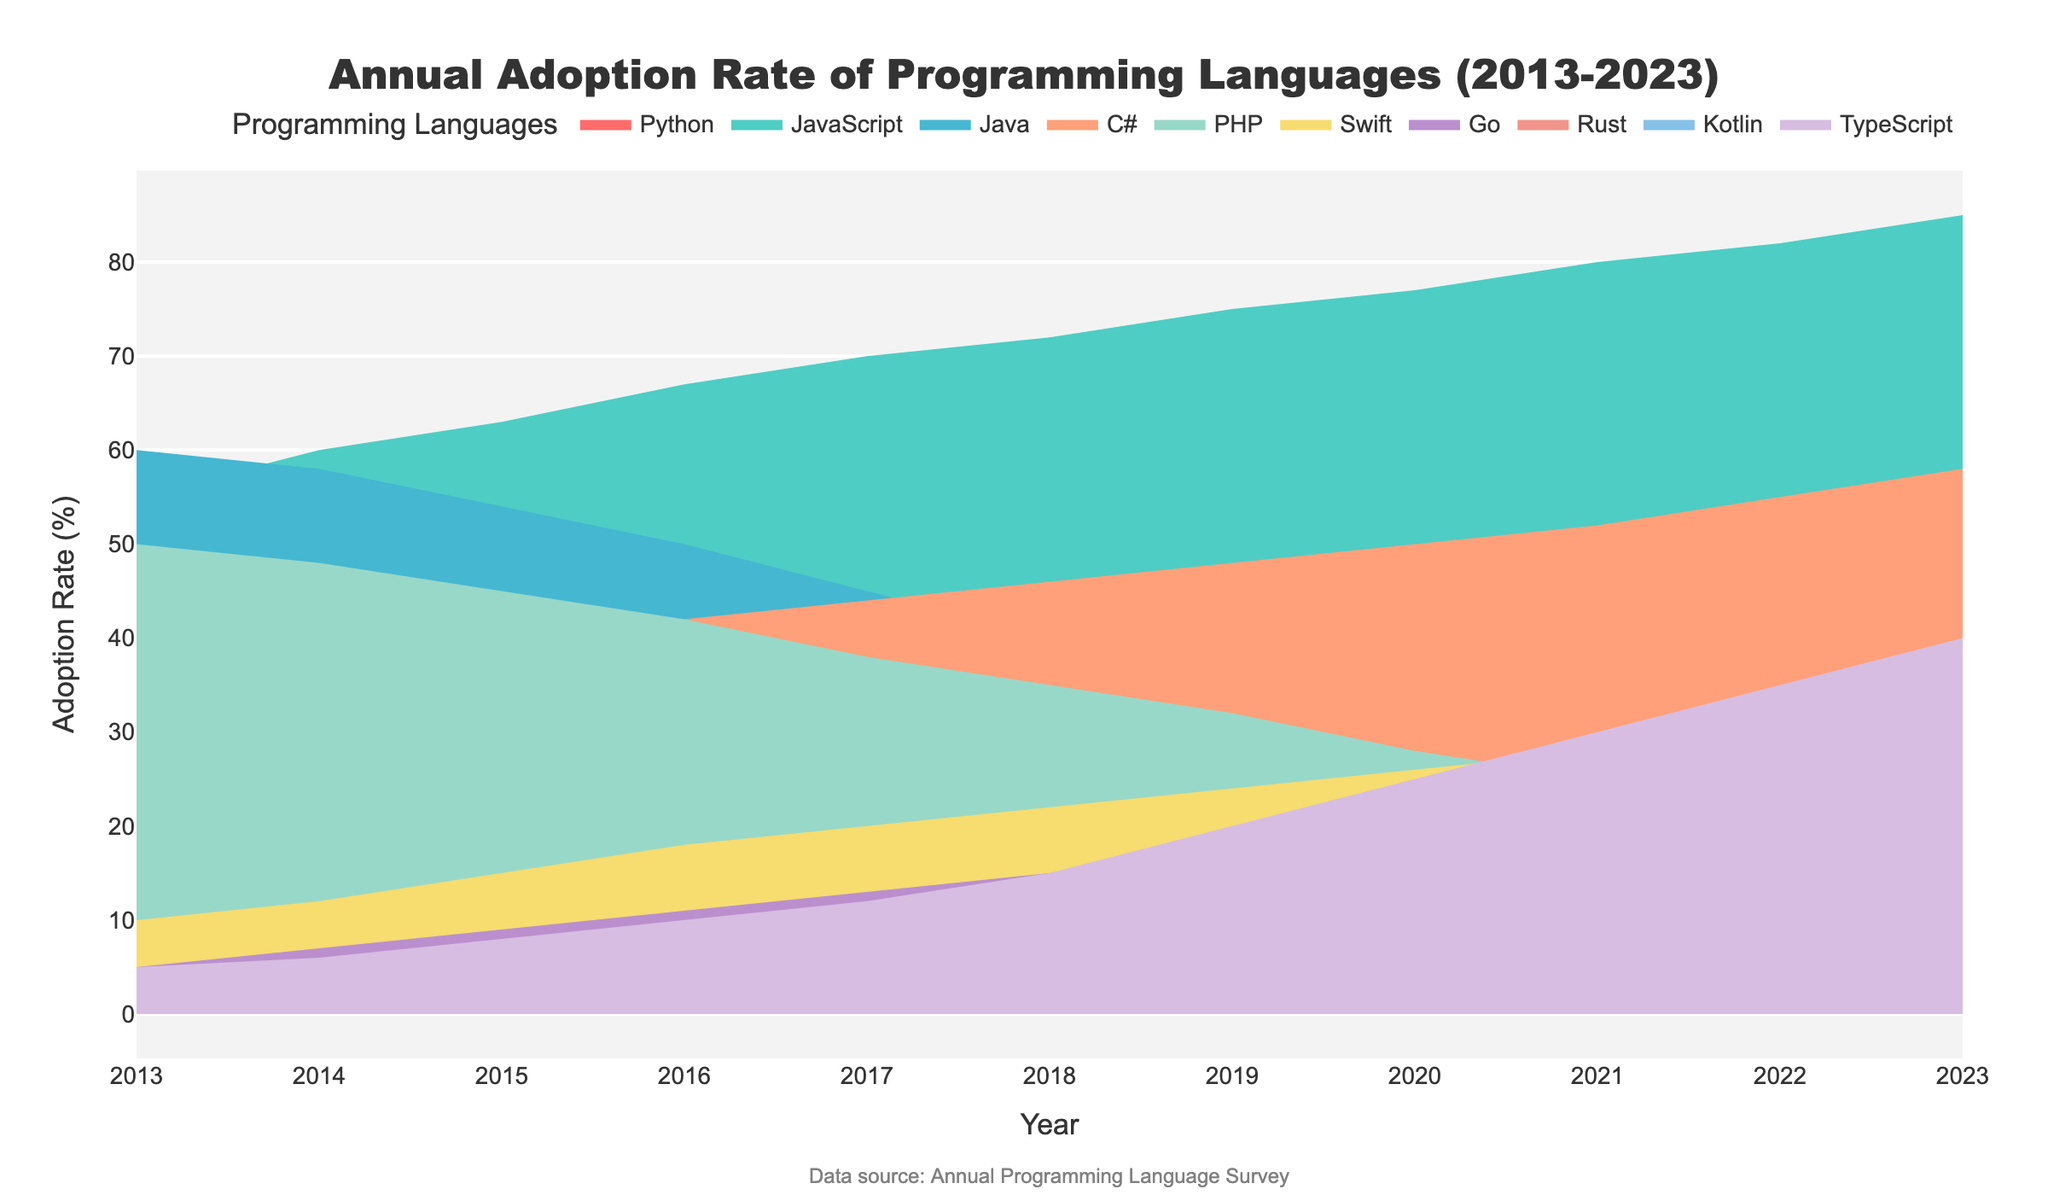What is the title of the chart? The title of the chart is displayed prominently at the top of the figure and reads "Annual Adoption Rate of Programming Languages (2013-2023)".
Answer: Annual Adoption Rate of Programming Languages (2013-2023) Which programming language has the highest adoption rate in 2023? Looking at the year 2023 on the x-axis and observing the heights of the color bands, the language with the highest band is JavaScript, reaching the highest point on the y-axis.
Answer: JavaScript What color represents the adoption rate of Python? The color band for Python is a prominent feature in the chart, and it is the first trace added with the color #FF6B6B, which is a shade of red.
Answer: Red In which year did Python adoption rate surpass 50%? By tracing the color band for Python along the x-axis, in the year 2019, the band reaches the 50% mark on the y-axis.
Answer: 2019 Which language shows a steady increase in adoption rate from 2013 to 2023? By observing the trend lines for all languages, we note that the bands for TypeScript show a consistent increase every year without any dips.
Answer: TypeScript Between which years did C# have a stable adoption rate? Following the band for C#, it maintains a steady position from 2020 to 2022 without any noticeable increase or decrease.
Answer: 2020 to 2022 How many languages saw their adoption rates decrease over the decade (2013-2023)? Observing the trend of each color band from 2013 to 2023, we can see that Java, PHP, and JavaScript have decreasing trends by the end of the period.
Answer: Three Which language had the lowest adoption rate in 2013, and what was its value? Looking at the starting points on the y-axis for each color band in 2013, Rust starts at the lowest position with an adoption rate of 1%.
Answer: Rust, 1% In which years did the adoption rate of Swift experience notable increments? By observing the Swift color band's step-like increases, the most significant increments occur in the years 2016 and 2023.
Answer: 2016 and 2023 Compare the adoption rates of Go and Kotlin in 2021. Which one is higher and by how much? From the chart, the adoption rate for Go in 2021 is at 21%, and for Kotlin, it is at 25%. Subtract 21 from 25 to get the difference.
Answer: Kotlin is higher by 4% 